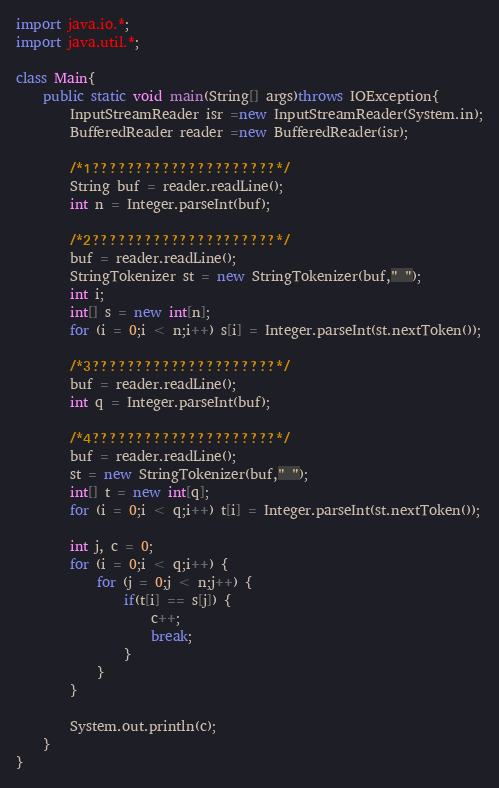Convert code to text. <code><loc_0><loc_0><loc_500><loc_500><_Java_>import java.io.*;
import java.util.*;

class Main{
    public static void main(String[] args)throws IOException{
        InputStreamReader isr =new InputStreamReader(System.in);
   		BufferedReader reader =new BufferedReader(isr);
    	
        /*1?????????????????????*/
        String buf = reader.readLine();
        int n = Integer.parseInt(buf);
        
        /*2?????????????????????*/
        buf = reader.readLine();
        StringTokenizer st = new StringTokenizer(buf," ");
        int i;
        int[] s = new int[n];
        for (i = 0;i < n;i++) s[i] = Integer.parseInt(st.nextToken());
        
        /*3?????????????????????*/
        buf = reader.readLine();
        int q = Integer.parseInt(buf);
        
        /*4?????????????????????*/
        buf = reader.readLine();
        st = new StringTokenizer(buf," ");
        int[] t = new int[q];
        for (i = 0;i < q;i++) t[i] = Integer.parseInt(st.nextToken());
        
        int j, c = 0;
        for (i = 0;i < q;i++) {
            for (j = 0;j < n;j++) {
                if(t[i] == s[j]) {
                    c++;
                    break;
                }
            }
        }
        
        System.out.println(c);
    }
}</code> 